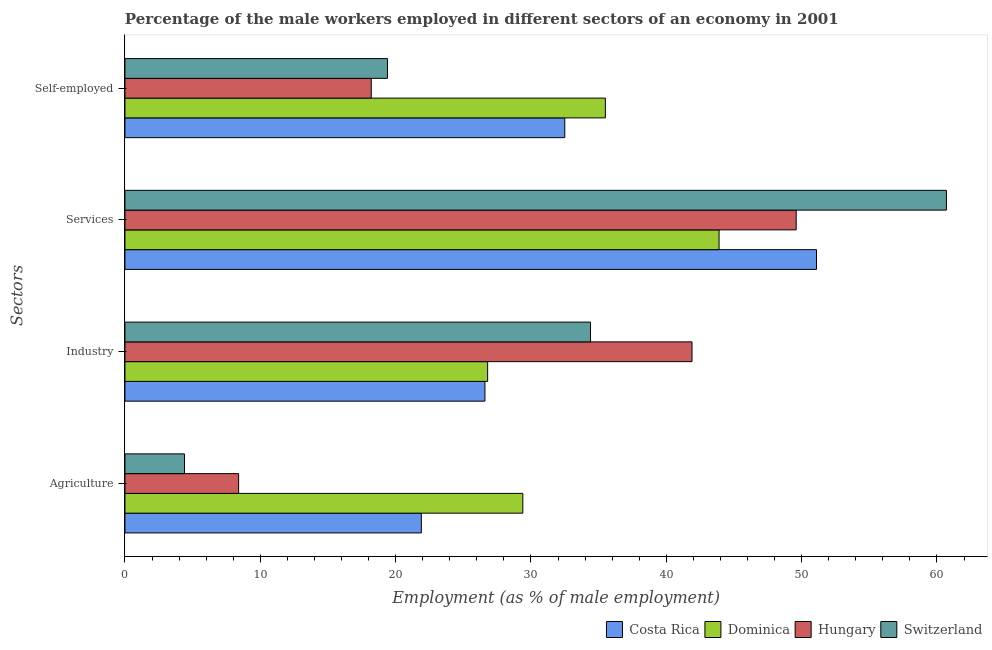How many different coloured bars are there?
Provide a succinct answer. 4. How many bars are there on the 4th tick from the bottom?
Make the answer very short. 4. What is the label of the 2nd group of bars from the top?
Your answer should be very brief. Services. What is the percentage of male workers in industry in Costa Rica?
Give a very brief answer. 26.6. Across all countries, what is the maximum percentage of self employed male workers?
Provide a succinct answer. 35.5. Across all countries, what is the minimum percentage of self employed male workers?
Keep it short and to the point. 18.2. In which country was the percentage of male workers in agriculture maximum?
Provide a short and direct response. Dominica. In which country was the percentage of male workers in industry minimum?
Offer a very short reply. Costa Rica. What is the total percentage of male workers in services in the graph?
Offer a terse response. 205.3. What is the difference between the percentage of male workers in agriculture in Dominica and that in Hungary?
Your answer should be compact. 21. What is the difference between the percentage of male workers in agriculture in Dominica and the percentage of self employed male workers in Costa Rica?
Your response must be concise. -3.1. What is the average percentage of male workers in agriculture per country?
Ensure brevity in your answer.  16.02. What is the difference between the percentage of male workers in industry and percentage of male workers in agriculture in Costa Rica?
Provide a succinct answer. 4.7. What is the ratio of the percentage of male workers in industry in Dominica to that in Hungary?
Provide a succinct answer. 0.64. Is the percentage of male workers in industry in Hungary less than that in Costa Rica?
Your answer should be compact. No. What is the difference between the highest and the second highest percentage of self employed male workers?
Make the answer very short. 3. What is the difference between the highest and the lowest percentage of self employed male workers?
Offer a very short reply. 17.3. In how many countries, is the percentage of male workers in industry greater than the average percentage of male workers in industry taken over all countries?
Offer a very short reply. 2. Is it the case that in every country, the sum of the percentage of self employed male workers and percentage of male workers in agriculture is greater than the sum of percentage of male workers in industry and percentage of male workers in services?
Provide a succinct answer. No. What does the 1st bar from the top in Self-employed represents?
Your answer should be very brief. Switzerland. What does the 2nd bar from the bottom in Services represents?
Offer a very short reply. Dominica. Is it the case that in every country, the sum of the percentage of male workers in agriculture and percentage of male workers in industry is greater than the percentage of male workers in services?
Provide a succinct answer. No. Are all the bars in the graph horizontal?
Ensure brevity in your answer.  Yes. Does the graph contain any zero values?
Ensure brevity in your answer.  No. Does the graph contain grids?
Make the answer very short. No. Where does the legend appear in the graph?
Give a very brief answer. Bottom right. How are the legend labels stacked?
Give a very brief answer. Horizontal. What is the title of the graph?
Keep it short and to the point. Percentage of the male workers employed in different sectors of an economy in 2001. Does "Nigeria" appear as one of the legend labels in the graph?
Make the answer very short. No. What is the label or title of the X-axis?
Offer a terse response. Employment (as % of male employment). What is the label or title of the Y-axis?
Keep it short and to the point. Sectors. What is the Employment (as % of male employment) of Costa Rica in Agriculture?
Give a very brief answer. 21.9. What is the Employment (as % of male employment) in Dominica in Agriculture?
Provide a short and direct response. 29.4. What is the Employment (as % of male employment) of Hungary in Agriculture?
Your answer should be compact. 8.4. What is the Employment (as % of male employment) of Switzerland in Agriculture?
Offer a very short reply. 4.4. What is the Employment (as % of male employment) in Costa Rica in Industry?
Make the answer very short. 26.6. What is the Employment (as % of male employment) in Dominica in Industry?
Provide a short and direct response. 26.8. What is the Employment (as % of male employment) of Hungary in Industry?
Your response must be concise. 41.9. What is the Employment (as % of male employment) of Switzerland in Industry?
Ensure brevity in your answer.  34.4. What is the Employment (as % of male employment) in Costa Rica in Services?
Your answer should be very brief. 51.1. What is the Employment (as % of male employment) of Dominica in Services?
Your response must be concise. 43.9. What is the Employment (as % of male employment) in Hungary in Services?
Your answer should be compact. 49.6. What is the Employment (as % of male employment) in Switzerland in Services?
Make the answer very short. 60.7. What is the Employment (as % of male employment) of Costa Rica in Self-employed?
Ensure brevity in your answer.  32.5. What is the Employment (as % of male employment) in Dominica in Self-employed?
Ensure brevity in your answer.  35.5. What is the Employment (as % of male employment) of Hungary in Self-employed?
Offer a very short reply. 18.2. What is the Employment (as % of male employment) in Switzerland in Self-employed?
Your answer should be very brief. 19.4. Across all Sectors, what is the maximum Employment (as % of male employment) in Costa Rica?
Keep it short and to the point. 51.1. Across all Sectors, what is the maximum Employment (as % of male employment) in Dominica?
Offer a terse response. 43.9. Across all Sectors, what is the maximum Employment (as % of male employment) in Hungary?
Provide a short and direct response. 49.6. Across all Sectors, what is the maximum Employment (as % of male employment) in Switzerland?
Give a very brief answer. 60.7. Across all Sectors, what is the minimum Employment (as % of male employment) in Costa Rica?
Offer a terse response. 21.9. Across all Sectors, what is the minimum Employment (as % of male employment) in Dominica?
Provide a short and direct response. 26.8. Across all Sectors, what is the minimum Employment (as % of male employment) of Hungary?
Provide a succinct answer. 8.4. Across all Sectors, what is the minimum Employment (as % of male employment) of Switzerland?
Give a very brief answer. 4.4. What is the total Employment (as % of male employment) in Costa Rica in the graph?
Provide a short and direct response. 132.1. What is the total Employment (as % of male employment) of Dominica in the graph?
Your answer should be compact. 135.6. What is the total Employment (as % of male employment) of Hungary in the graph?
Ensure brevity in your answer.  118.1. What is the total Employment (as % of male employment) of Switzerland in the graph?
Give a very brief answer. 118.9. What is the difference between the Employment (as % of male employment) in Costa Rica in Agriculture and that in Industry?
Offer a terse response. -4.7. What is the difference between the Employment (as % of male employment) in Hungary in Agriculture and that in Industry?
Provide a short and direct response. -33.5. What is the difference between the Employment (as % of male employment) in Costa Rica in Agriculture and that in Services?
Provide a succinct answer. -29.2. What is the difference between the Employment (as % of male employment) in Hungary in Agriculture and that in Services?
Provide a short and direct response. -41.2. What is the difference between the Employment (as % of male employment) of Switzerland in Agriculture and that in Services?
Offer a very short reply. -56.3. What is the difference between the Employment (as % of male employment) of Dominica in Agriculture and that in Self-employed?
Make the answer very short. -6.1. What is the difference between the Employment (as % of male employment) in Switzerland in Agriculture and that in Self-employed?
Offer a very short reply. -15. What is the difference between the Employment (as % of male employment) in Costa Rica in Industry and that in Services?
Provide a short and direct response. -24.5. What is the difference between the Employment (as % of male employment) in Dominica in Industry and that in Services?
Your answer should be compact. -17.1. What is the difference between the Employment (as % of male employment) in Switzerland in Industry and that in Services?
Ensure brevity in your answer.  -26.3. What is the difference between the Employment (as % of male employment) of Hungary in Industry and that in Self-employed?
Make the answer very short. 23.7. What is the difference between the Employment (as % of male employment) in Hungary in Services and that in Self-employed?
Ensure brevity in your answer.  31.4. What is the difference between the Employment (as % of male employment) of Switzerland in Services and that in Self-employed?
Ensure brevity in your answer.  41.3. What is the difference between the Employment (as % of male employment) of Costa Rica in Agriculture and the Employment (as % of male employment) of Hungary in Industry?
Make the answer very short. -20. What is the difference between the Employment (as % of male employment) in Dominica in Agriculture and the Employment (as % of male employment) in Hungary in Industry?
Ensure brevity in your answer.  -12.5. What is the difference between the Employment (as % of male employment) of Dominica in Agriculture and the Employment (as % of male employment) of Switzerland in Industry?
Provide a short and direct response. -5. What is the difference between the Employment (as % of male employment) in Costa Rica in Agriculture and the Employment (as % of male employment) in Dominica in Services?
Your answer should be compact. -22. What is the difference between the Employment (as % of male employment) of Costa Rica in Agriculture and the Employment (as % of male employment) of Hungary in Services?
Keep it short and to the point. -27.7. What is the difference between the Employment (as % of male employment) in Costa Rica in Agriculture and the Employment (as % of male employment) in Switzerland in Services?
Give a very brief answer. -38.8. What is the difference between the Employment (as % of male employment) of Dominica in Agriculture and the Employment (as % of male employment) of Hungary in Services?
Offer a very short reply. -20.2. What is the difference between the Employment (as % of male employment) of Dominica in Agriculture and the Employment (as % of male employment) of Switzerland in Services?
Ensure brevity in your answer.  -31.3. What is the difference between the Employment (as % of male employment) of Hungary in Agriculture and the Employment (as % of male employment) of Switzerland in Services?
Ensure brevity in your answer.  -52.3. What is the difference between the Employment (as % of male employment) in Costa Rica in Agriculture and the Employment (as % of male employment) in Dominica in Self-employed?
Your answer should be compact. -13.6. What is the difference between the Employment (as % of male employment) of Dominica in Agriculture and the Employment (as % of male employment) of Switzerland in Self-employed?
Ensure brevity in your answer.  10. What is the difference between the Employment (as % of male employment) in Hungary in Agriculture and the Employment (as % of male employment) in Switzerland in Self-employed?
Ensure brevity in your answer.  -11. What is the difference between the Employment (as % of male employment) in Costa Rica in Industry and the Employment (as % of male employment) in Dominica in Services?
Make the answer very short. -17.3. What is the difference between the Employment (as % of male employment) of Costa Rica in Industry and the Employment (as % of male employment) of Hungary in Services?
Make the answer very short. -23. What is the difference between the Employment (as % of male employment) of Costa Rica in Industry and the Employment (as % of male employment) of Switzerland in Services?
Your response must be concise. -34.1. What is the difference between the Employment (as % of male employment) of Dominica in Industry and the Employment (as % of male employment) of Hungary in Services?
Your answer should be compact. -22.8. What is the difference between the Employment (as % of male employment) of Dominica in Industry and the Employment (as % of male employment) of Switzerland in Services?
Make the answer very short. -33.9. What is the difference between the Employment (as % of male employment) in Hungary in Industry and the Employment (as % of male employment) in Switzerland in Services?
Keep it short and to the point. -18.8. What is the difference between the Employment (as % of male employment) of Costa Rica in Industry and the Employment (as % of male employment) of Hungary in Self-employed?
Your response must be concise. 8.4. What is the difference between the Employment (as % of male employment) of Costa Rica in Services and the Employment (as % of male employment) of Hungary in Self-employed?
Ensure brevity in your answer.  32.9. What is the difference between the Employment (as % of male employment) of Costa Rica in Services and the Employment (as % of male employment) of Switzerland in Self-employed?
Offer a very short reply. 31.7. What is the difference between the Employment (as % of male employment) in Dominica in Services and the Employment (as % of male employment) in Hungary in Self-employed?
Provide a short and direct response. 25.7. What is the difference between the Employment (as % of male employment) in Hungary in Services and the Employment (as % of male employment) in Switzerland in Self-employed?
Provide a succinct answer. 30.2. What is the average Employment (as % of male employment) in Costa Rica per Sectors?
Keep it short and to the point. 33.02. What is the average Employment (as % of male employment) of Dominica per Sectors?
Ensure brevity in your answer.  33.9. What is the average Employment (as % of male employment) of Hungary per Sectors?
Keep it short and to the point. 29.52. What is the average Employment (as % of male employment) of Switzerland per Sectors?
Offer a terse response. 29.73. What is the difference between the Employment (as % of male employment) of Costa Rica and Employment (as % of male employment) of Dominica in Agriculture?
Offer a very short reply. -7.5. What is the difference between the Employment (as % of male employment) of Hungary and Employment (as % of male employment) of Switzerland in Agriculture?
Ensure brevity in your answer.  4. What is the difference between the Employment (as % of male employment) in Costa Rica and Employment (as % of male employment) in Dominica in Industry?
Your answer should be very brief. -0.2. What is the difference between the Employment (as % of male employment) of Costa Rica and Employment (as % of male employment) of Hungary in Industry?
Your answer should be compact. -15.3. What is the difference between the Employment (as % of male employment) in Costa Rica and Employment (as % of male employment) in Switzerland in Industry?
Your response must be concise. -7.8. What is the difference between the Employment (as % of male employment) in Dominica and Employment (as % of male employment) in Hungary in Industry?
Provide a short and direct response. -15.1. What is the difference between the Employment (as % of male employment) of Dominica and Employment (as % of male employment) of Switzerland in Industry?
Your answer should be very brief. -7.6. What is the difference between the Employment (as % of male employment) in Hungary and Employment (as % of male employment) in Switzerland in Industry?
Provide a short and direct response. 7.5. What is the difference between the Employment (as % of male employment) in Costa Rica and Employment (as % of male employment) in Dominica in Services?
Your answer should be very brief. 7.2. What is the difference between the Employment (as % of male employment) of Costa Rica and Employment (as % of male employment) of Hungary in Services?
Your answer should be compact. 1.5. What is the difference between the Employment (as % of male employment) of Dominica and Employment (as % of male employment) of Switzerland in Services?
Your response must be concise. -16.8. What is the difference between the Employment (as % of male employment) in Costa Rica and Employment (as % of male employment) in Hungary in Self-employed?
Offer a terse response. 14.3. What is the difference between the Employment (as % of male employment) of Costa Rica and Employment (as % of male employment) of Switzerland in Self-employed?
Give a very brief answer. 13.1. What is the difference between the Employment (as % of male employment) of Dominica and Employment (as % of male employment) of Switzerland in Self-employed?
Your response must be concise. 16.1. What is the ratio of the Employment (as % of male employment) of Costa Rica in Agriculture to that in Industry?
Give a very brief answer. 0.82. What is the ratio of the Employment (as % of male employment) of Dominica in Agriculture to that in Industry?
Your answer should be very brief. 1.1. What is the ratio of the Employment (as % of male employment) in Hungary in Agriculture to that in Industry?
Make the answer very short. 0.2. What is the ratio of the Employment (as % of male employment) of Switzerland in Agriculture to that in Industry?
Keep it short and to the point. 0.13. What is the ratio of the Employment (as % of male employment) of Costa Rica in Agriculture to that in Services?
Provide a short and direct response. 0.43. What is the ratio of the Employment (as % of male employment) of Dominica in Agriculture to that in Services?
Keep it short and to the point. 0.67. What is the ratio of the Employment (as % of male employment) in Hungary in Agriculture to that in Services?
Your answer should be compact. 0.17. What is the ratio of the Employment (as % of male employment) of Switzerland in Agriculture to that in Services?
Your answer should be very brief. 0.07. What is the ratio of the Employment (as % of male employment) of Costa Rica in Agriculture to that in Self-employed?
Offer a very short reply. 0.67. What is the ratio of the Employment (as % of male employment) in Dominica in Agriculture to that in Self-employed?
Your response must be concise. 0.83. What is the ratio of the Employment (as % of male employment) of Hungary in Agriculture to that in Self-employed?
Your answer should be very brief. 0.46. What is the ratio of the Employment (as % of male employment) of Switzerland in Agriculture to that in Self-employed?
Provide a succinct answer. 0.23. What is the ratio of the Employment (as % of male employment) of Costa Rica in Industry to that in Services?
Give a very brief answer. 0.52. What is the ratio of the Employment (as % of male employment) in Dominica in Industry to that in Services?
Your answer should be very brief. 0.61. What is the ratio of the Employment (as % of male employment) of Hungary in Industry to that in Services?
Provide a succinct answer. 0.84. What is the ratio of the Employment (as % of male employment) in Switzerland in Industry to that in Services?
Your response must be concise. 0.57. What is the ratio of the Employment (as % of male employment) of Costa Rica in Industry to that in Self-employed?
Provide a short and direct response. 0.82. What is the ratio of the Employment (as % of male employment) of Dominica in Industry to that in Self-employed?
Your answer should be very brief. 0.75. What is the ratio of the Employment (as % of male employment) in Hungary in Industry to that in Self-employed?
Your answer should be very brief. 2.3. What is the ratio of the Employment (as % of male employment) of Switzerland in Industry to that in Self-employed?
Make the answer very short. 1.77. What is the ratio of the Employment (as % of male employment) of Costa Rica in Services to that in Self-employed?
Your answer should be compact. 1.57. What is the ratio of the Employment (as % of male employment) of Dominica in Services to that in Self-employed?
Keep it short and to the point. 1.24. What is the ratio of the Employment (as % of male employment) of Hungary in Services to that in Self-employed?
Give a very brief answer. 2.73. What is the ratio of the Employment (as % of male employment) of Switzerland in Services to that in Self-employed?
Provide a succinct answer. 3.13. What is the difference between the highest and the second highest Employment (as % of male employment) of Hungary?
Offer a very short reply. 7.7. What is the difference between the highest and the second highest Employment (as % of male employment) of Switzerland?
Give a very brief answer. 26.3. What is the difference between the highest and the lowest Employment (as % of male employment) in Costa Rica?
Provide a succinct answer. 29.2. What is the difference between the highest and the lowest Employment (as % of male employment) in Hungary?
Give a very brief answer. 41.2. What is the difference between the highest and the lowest Employment (as % of male employment) of Switzerland?
Offer a very short reply. 56.3. 